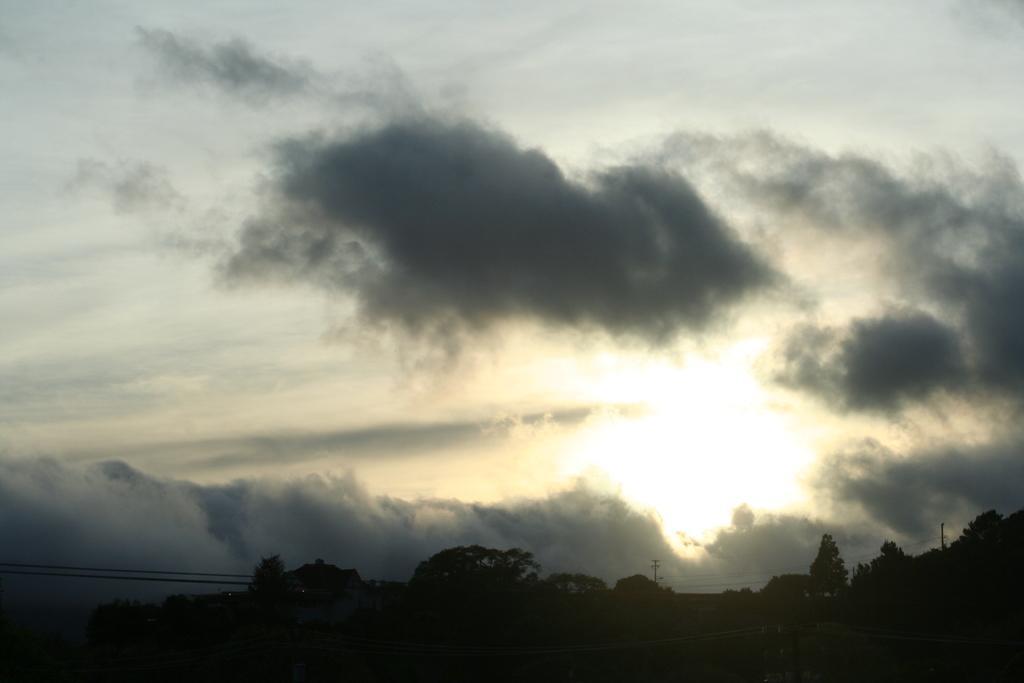In one or two sentences, can you explain what this image depicts? At the bottom of the picture, it is black in color. There are trees, electric poles and wires in the background. At the top of the picture, we see the sky and the sun. This picture might be clicked in the early morning. 